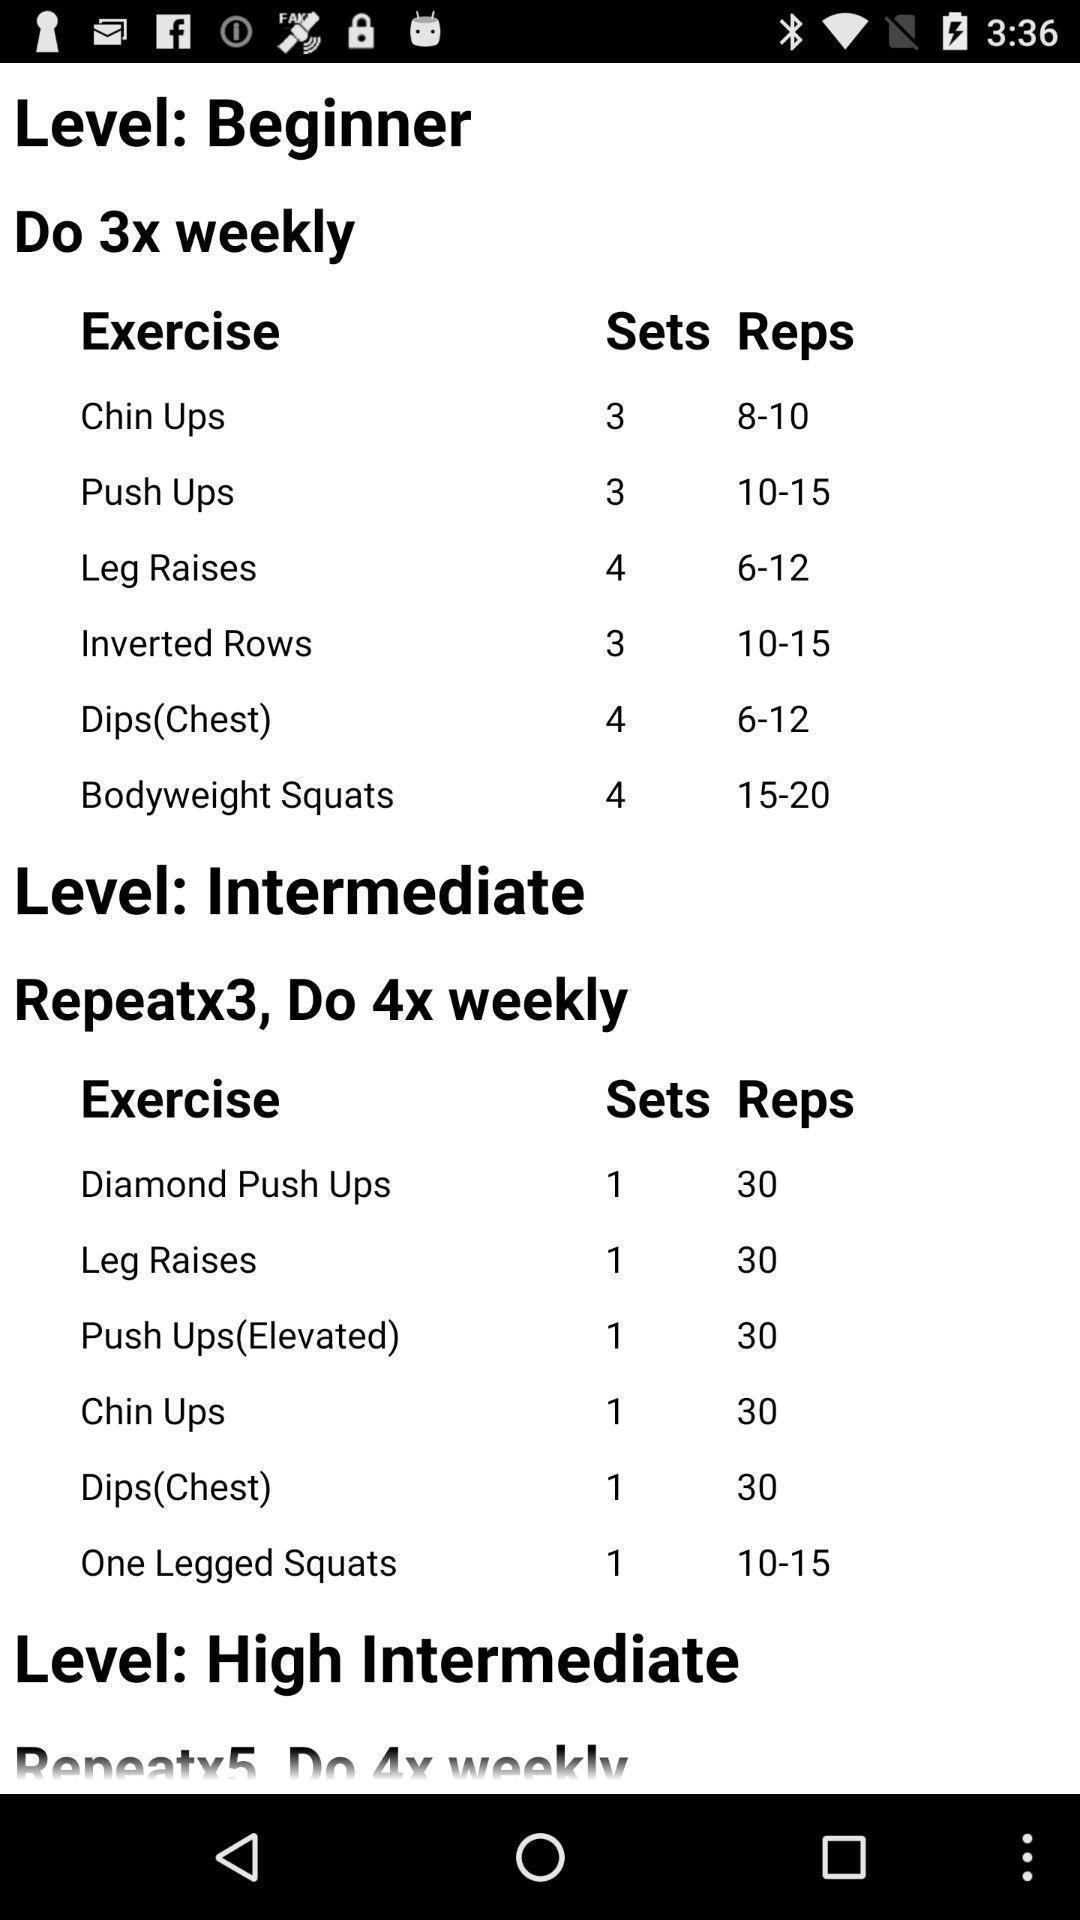Give me a summary of this screen capture. Page showing information about an application. 